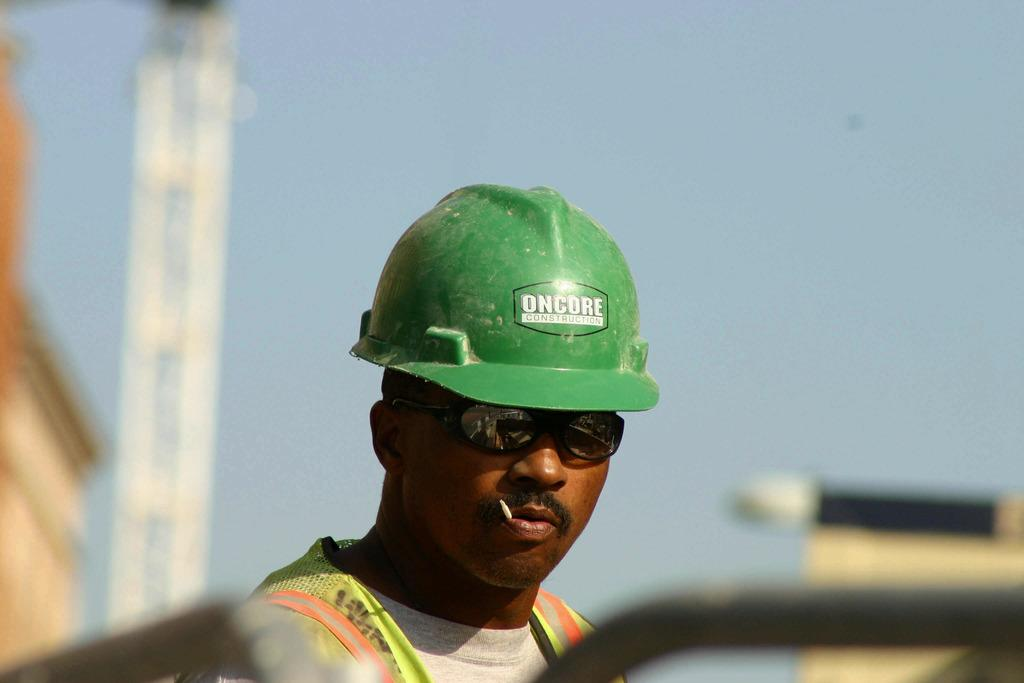What is the main subject of the picture? The main subject of the picture is a person. Can you describe the person's appearance? The person is wearing spectacles and a helmet. What type of tin can be seen in the picture? There is no tin present in the picture; it features a person wearing spectacles and a helmet. How many giraffes are visible in the picture? There are no giraffes visible in the picture; it features a person wearing spectacles and a helmet. 